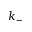<formula> <loc_0><loc_0><loc_500><loc_500>k _ { - }</formula> 